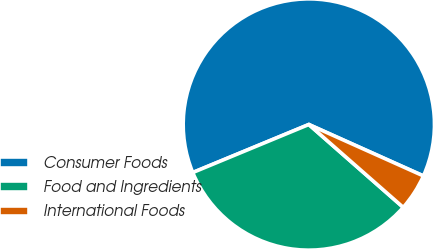<chart> <loc_0><loc_0><loc_500><loc_500><pie_chart><fcel>Consumer Foods<fcel>Food and Ingredients<fcel>International Foods<nl><fcel>62.95%<fcel>32.29%<fcel>4.75%<nl></chart> 